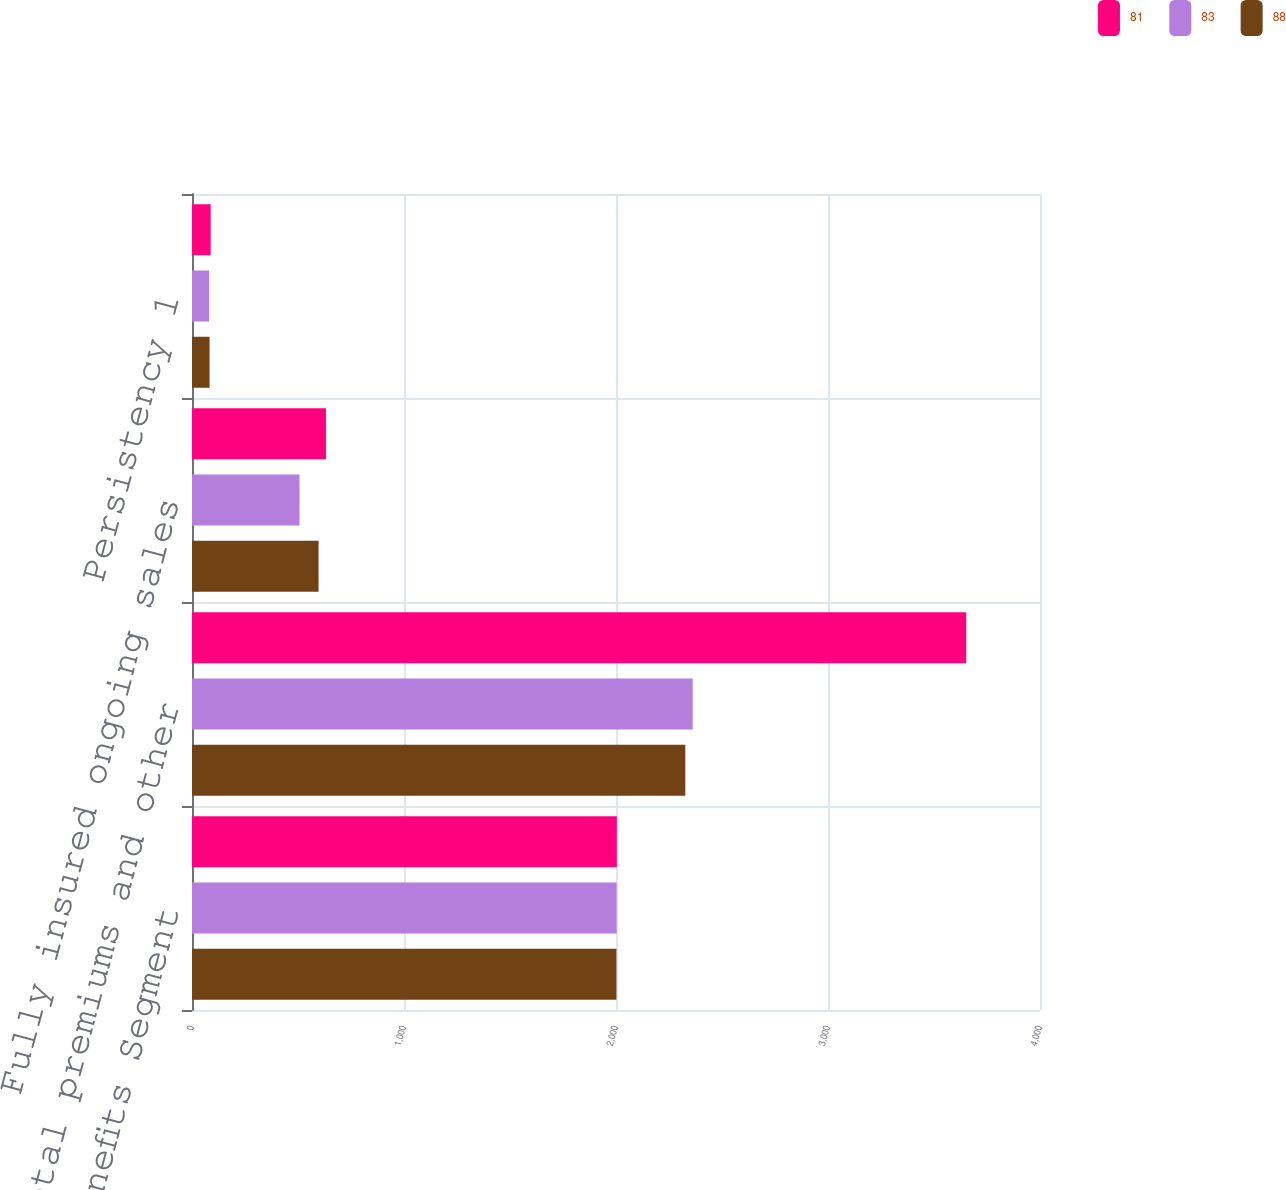Convert chart. <chart><loc_0><loc_0><loc_500><loc_500><stacked_bar_chart><ecel><fcel>Group Benefits Segment<fcel>Total premiums and other<fcel>Fully insured ongoing sales<fcel>Persistency 1<nl><fcel>81<fcel>2004<fcel>3652<fcel>632<fcel>88<nl><fcel>83<fcel>2003<fcel>2362<fcel>507<fcel>81<nl><fcel>88<fcel>2002<fcel>2327<fcel>597<fcel>83<nl></chart> 